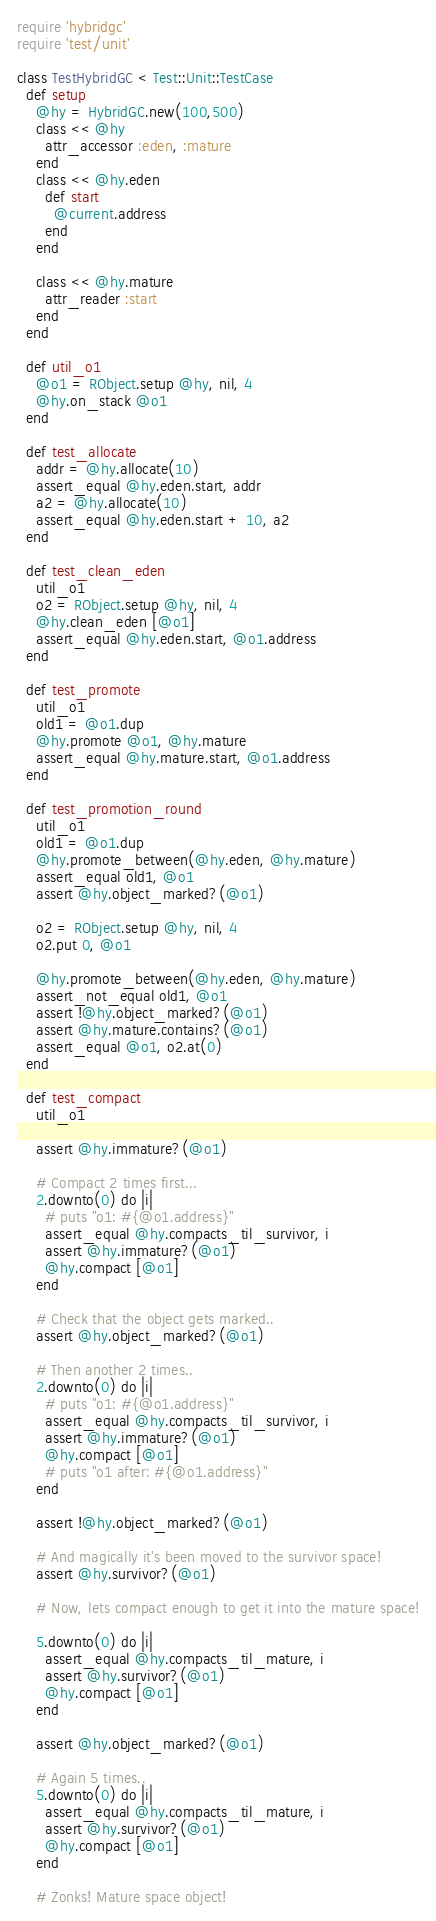Convert code to text. <code><loc_0><loc_0><loc_500><loc_500><_Ruby_>require 'hybridgc'
require 'test/unit'

class TestHybridGC < Test::Unit::TestCase
  def setup
    @hy = HybridGC.new(100,500)
    class << @hy
      attr_accessor :eden, :mature
    end
    class << @hy.eden
      def start
        @current.address
      end
    end
    
    class << @hy.mature
      attr_reader :start
    end
  end
  
  def util_o1
    @o1 = RObject.setup @hy, nil, 4
    @hy.on_stack @o1
  end
  
  def test_allocate
    addr = @hy.allocate(10)
    assert_equal @hy.eden.start, addr
    a2 = @hy.allocate(10)
    assert_equal @hy.eden.start + 10, a2
  end
  
  def test_clean_eden
    util_o1
    o2 = RObject.setup @hy, nil, 4
    @hy.clean_eden [@o1]
    assert_equal @hy.eden.start, @o1.address
  end
  
  def test_promote
    util_o1
    old1 = @o1.dup
    @hy.promote @o1, @hy.mature
    assert_equal @hy.mature.start, @o1.address
  end
  
  def test_promotion_round
    util_o1
    old1 = @o1.dup
    @hy.promote_between(@hy.eden, @hy.mature)
    assert_equal old1, @o1
    assert @hy.object_marked?(@o1)
    
    o2 = RObject.setup @hy, nil, 4
    o2.put 0, @o1
    
    @hy.promote_between(@hy.eden, @hy.mature)
    assert_not_equal old1, @o1
    assert !@hy.object_marked?(@o1)
    assert @hy.mature.contains?(@o1)
    assert_equal @o1, o2.at(0)
  end
  
  def test_compact
    util_o1
    
    assert @hy.immature?(@o1)
    
    # Compact 2 times first...
    2.downto(0) do |i|
      # puts "o1: #{@o1.address}"
      assert_equal @hy.compacts_til_survivor, i
      assert @hy.immature?(@o1)
      @hy.compact [@o1]
    end
        
    # Check that the object gets marked..
    assert @hy.object_marked?(@o1)
    
    # Then another 2 times..
    2.downto(0) do |i|
      # puts "o1: #{@o1.address}"
      assert_equal @hy.compacts_til_survivor, i
      assert @hy.immature?(@o1)
      @hy.compact [@o1]
      # puts "o1 after: #{@o1.address}"
    end
    
    assert !@hy.object_marked?(@o1)
    
    # And magically it's been moved to the survivor space!
    assert @hy.survivor?(@o1)
    
    # Now, lets compact enough to get it into the mature space!
    
    5.downto(0) do |i|
      assert_equal @hy.compacts_til_mature, i
      assert @hy.survivor?(@o1)
      @hy.compact [@o1]
    end
    
    assert @hy.object_marked?(@o1)
    
    # Again 5 times..
    5.downto(0) do |i|
      assert_equal @hy.compacts_til_mature, i
      assert @hy.survivor?(@o1)
      @hy.compact [@o1]
    end
    
    # Zonks! Mature space object!</code> 